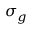Convert formula to latex. <formula><loc_0><loc_0><loc_500><loc_500>\sigma _ { g }</formula> 